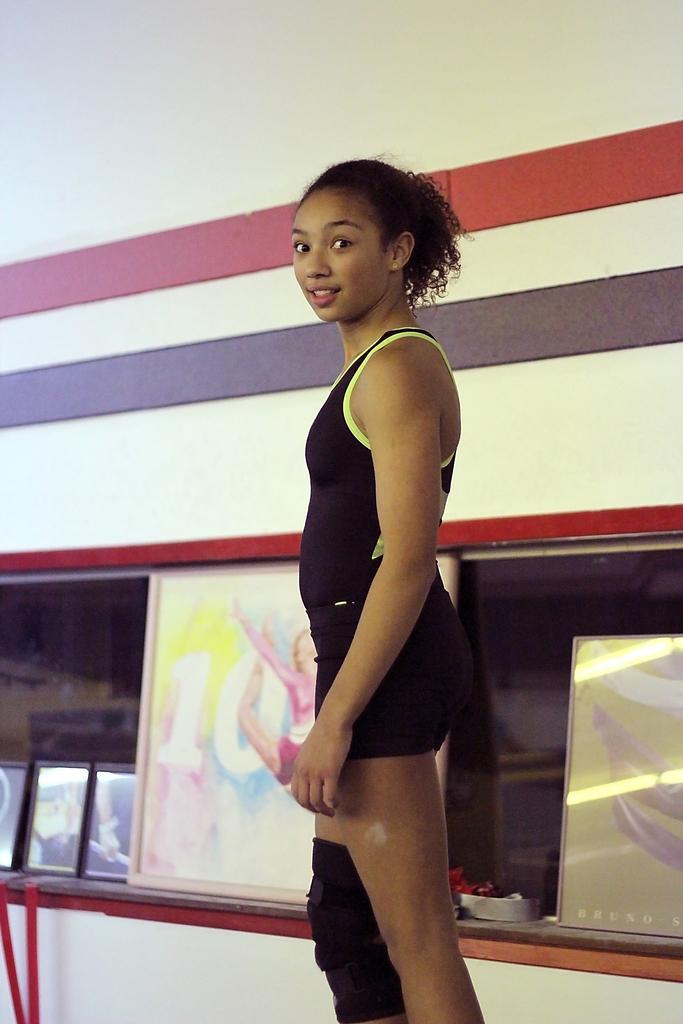In one or two sentences, can you explain what this image depicts? In the picture I can see a woman wearing a black color dress is standing here and smiling. In the background, we can see the photo frames and the white color wall. 